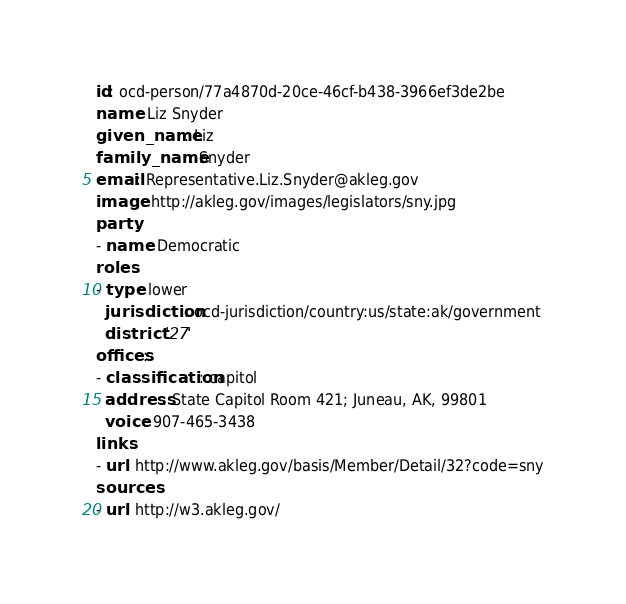<code> <loc_0><loc_0><loc_500><loc_500><_YAML_>id: ocd-person/77a4870d-20ce-46cf-b438-3966ef3de2be
name: Liz Snyder
given_name: Liz
family_name: Snyder
email: Representative.Liz.Snyder@akleg.gov
image: http://akleg.gov/images/legislators/sny.jpg
party:
- name: Democratic
roles:
- type: lower
  jurisdiction: ocd-jurisdiction/country:us/state:ak/government
  district: '27'
offices:
- classification: capitol
  address: State Capitol Room 421; Juneau, AK, 99801
  voice: 907-465-3438
links:
- url: http://www.akleg.gov/basis/Member/Detail/32?code=sny
sources:
- url: http://w3.akleg.gov/
</code> 